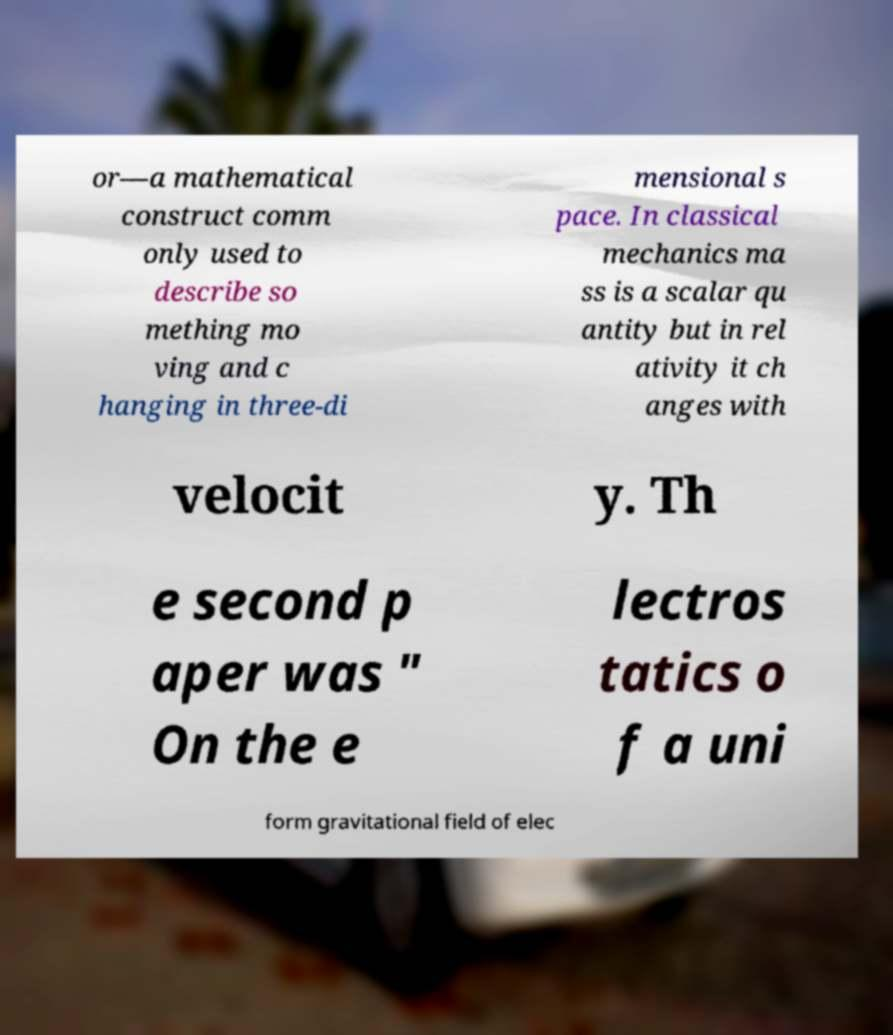For documentation purposes, I need the text within this image transcribed. Could you provide that? or—a mathematical construct comm only used to describe so mething mo ving and c hanging in three-di mensional s pace. In classical mechanics ma ss is a scalar qu antity but in rel ativity it ch anges with velocit y. Th e second p aper was " On the e lectros tatics o f a uni form gravitational field of elec 